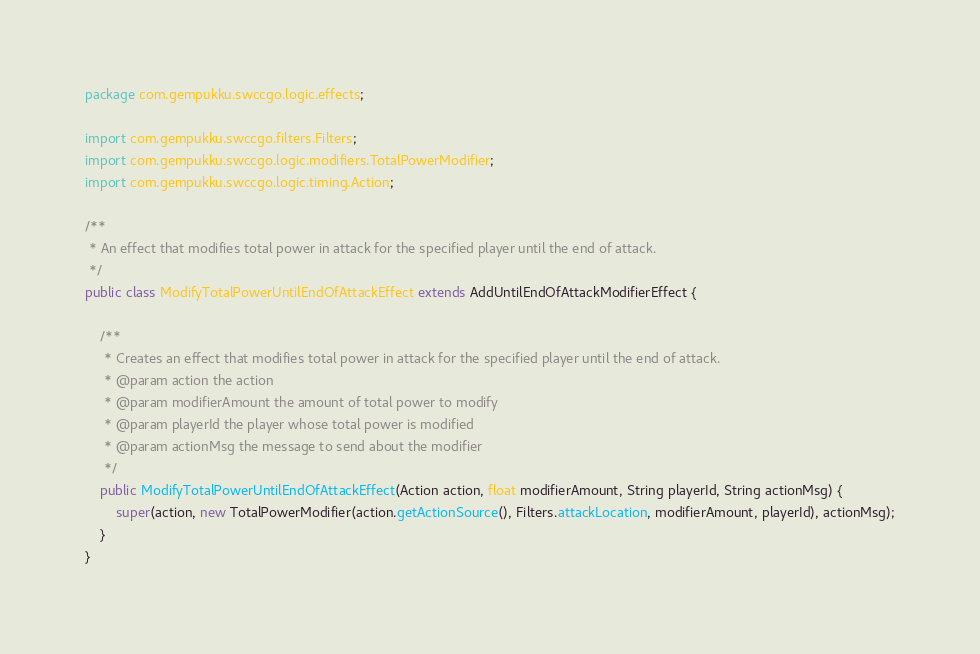<code> <loc_0><loc_0><loc_500><loc_500><_Java_>package com.gempukku.swccgo.logic.effects;

import com.gempukku.swccgo.filters.Filters;
import com.gempukku.swccgo.logic.modifiers.TotalPowerModifier;
import com.gempukku.swccgo.logic.timing.Action;

/**
 * An effect that modifies total power in attack for the specified player until the end of attack.
 */
public class ModifyTotalPowerUntilEndOfAttackEffect extends AddUntilEndOfAttackModifierEffect {

    /**
     * Creates an effect that modifies total power in attack for the specified player until the end of attack.
     * @param action the action
     * @param modifierAmount the amount of total power to modify
     * @param playerId the player whose total power is modified
     * @param actionMsg the message to send about the modifier
     */
    public ModifyTotalPowerUntilEndOfAttackEffect(Action action, float modifierAmount, String playerId, String actionMsg) {
        super(action, new TotalPowerModifier(action.getActionSource(), Filters.attackLocation, modifierAmount, playerId), actionMsg);
    }
}
</code> 